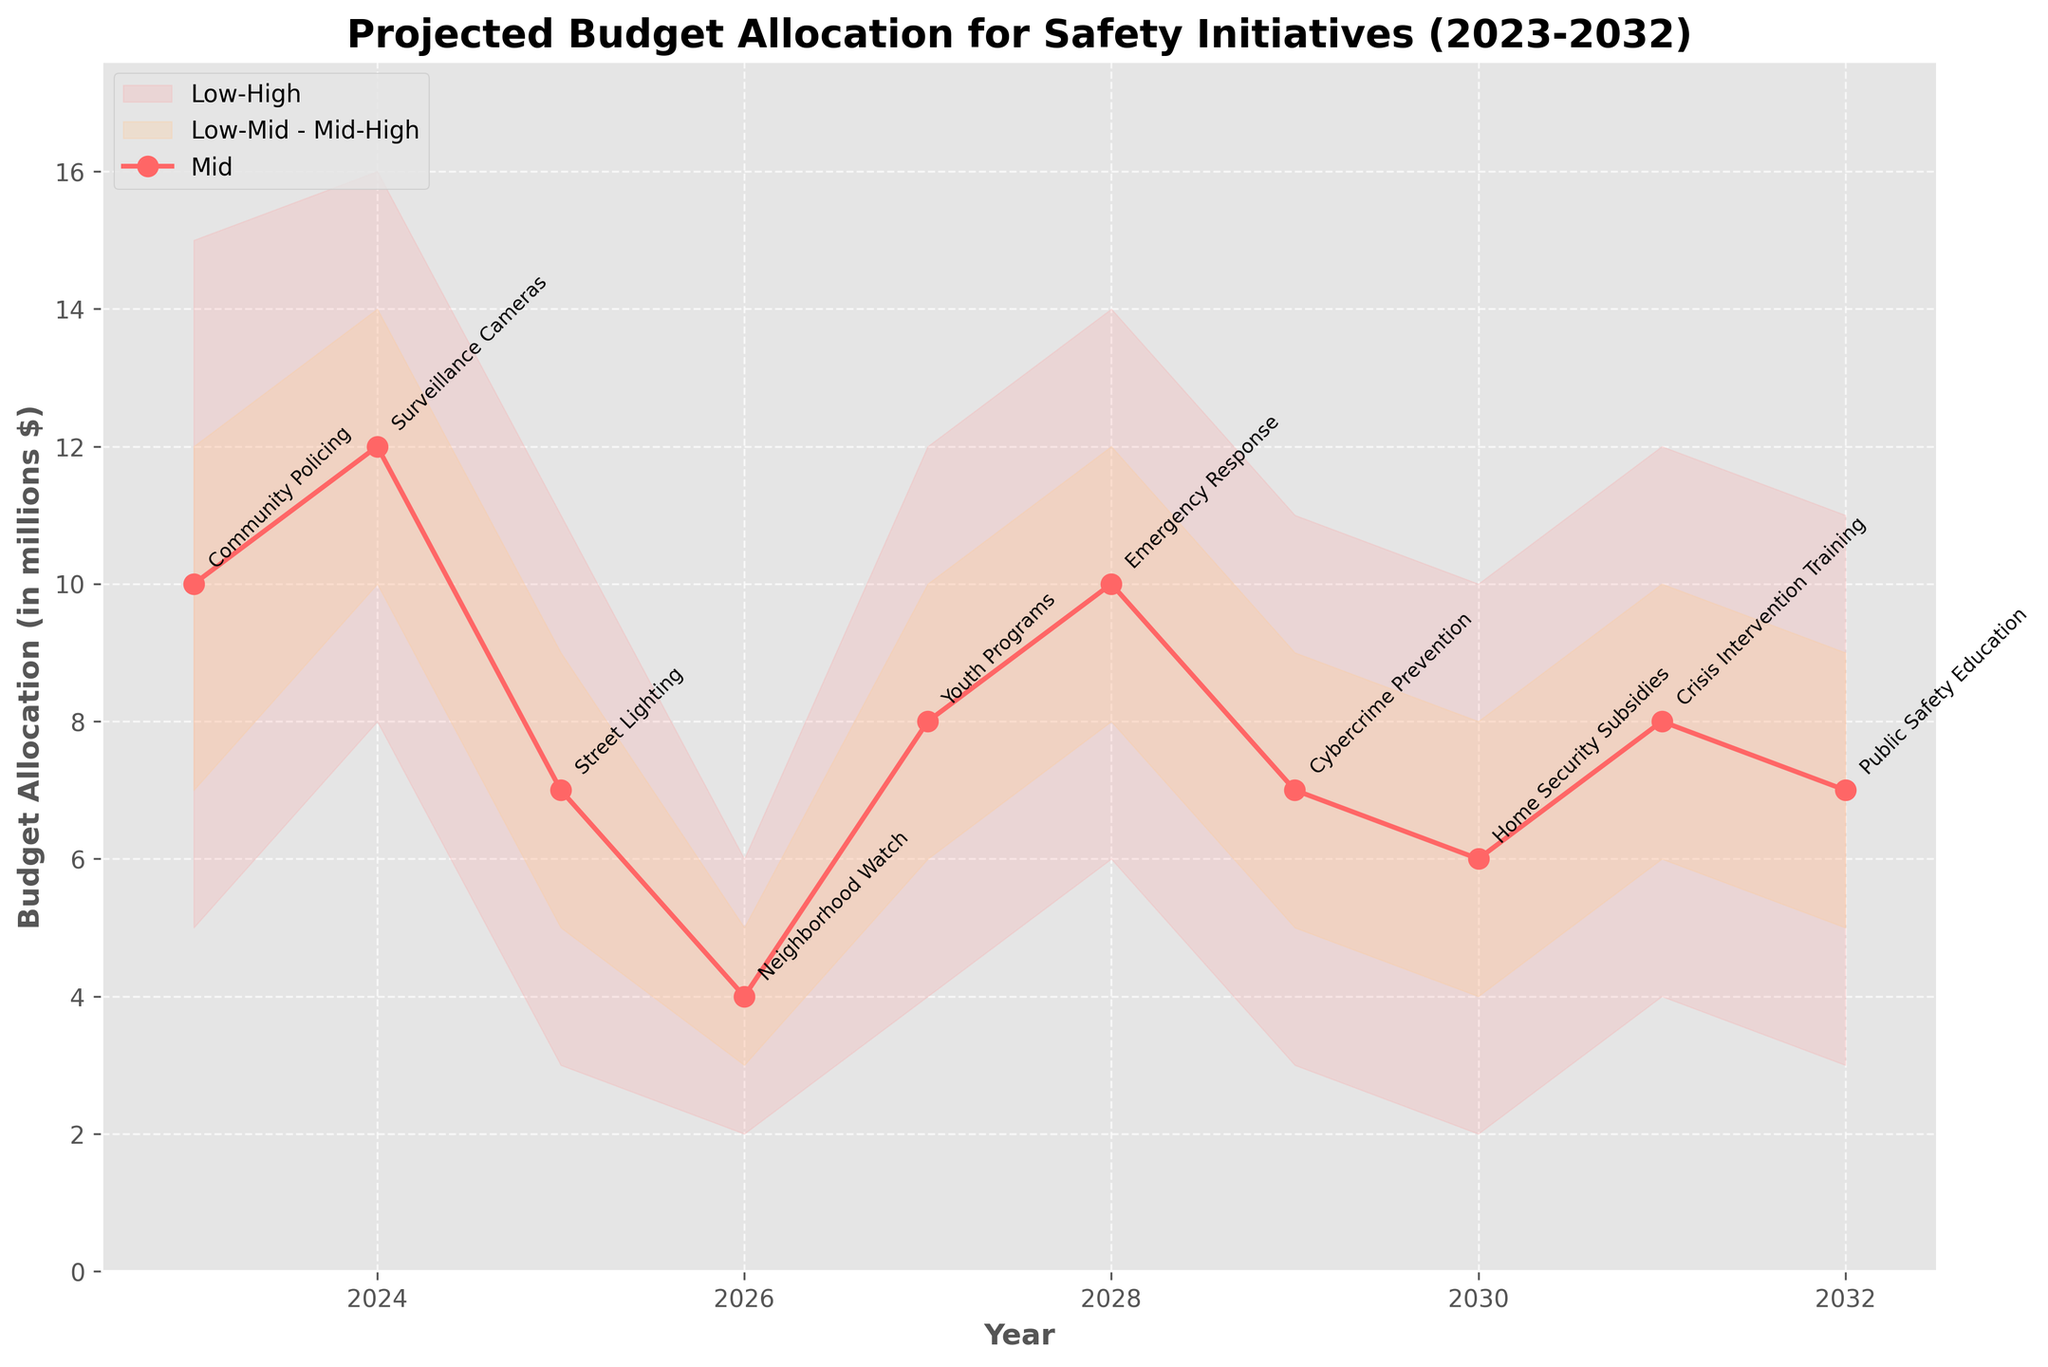What is the title of the chart? The title is located at the top of the chart and describes the overall theme or subject of the chart.
Answer: Projected Budget Allocation for Safety Initiatives (2023-2032) What is the projected budget allocation for Community Policing in 2023? The budget allocation for each initiative is represented by different points on the chart. Look for the point labeled "Community Policing" on the x-axis for the year 2023, and then trace it up to the y-axis value of the "Mid" line.
Answer: 10 million dollars Which year has the highest "High" projection for Emergency Response? The "High" projections are the top bound of the shaded areas. Locate the line segment for Emergency Response and find the year where this line reaches its highest point.
Answer: 2028 What is the difference between the "Mid" projections of Surveillance Cameras in 2024 and Cybercrime Prevention in 2029? Locate the "Mid" projections values for both years and initiatives. Then, subtract the "Mid" value of Cybercrime Prevention in 2029 from the "Mid" value of Surveillance Cameras in 2024.
Answer: 5 million dollars Compare the "Low-Mid" budget projections for Youth Programs in 2027 and Neighborhood Watch in 2026. Which one is higher? Check the "Low-Mid" budget projection values in the years 2027 and 2026 for Youth Programs and Neighborhood Watch, respectively. Compare these values.
Answer: Youth Programs How does the range of projected budget allocations for Home Security Subsidies in 2030 compare with Public Safety Education in 2032? Look at the shaded area differences (Low to High) for both initiatives in their respective years, then compare these ranges directly.
Answer: Home Security Subsidies has a smaller range than Public Safety Education What is the projected "Mid-High" value for Street Lighting in 2025? Locate the year 2025 on the x-axis and find the "Mid-High" value by tracing up to the corresponding level in the chart for Street Lighting.
Answer: 9 million dollars Are the budget projections for Crisis Intervention Training higher or lower than for Youth Programs in their respective years of 2031 and 2027, based on the "Mid" values? Compare the "Mid" projections of Crisis Intervention Training in 2031 and Youth Programs in 2027. Check which value is higher.
Answer: Equal Which initiative has the lowest "Low" budget projection in any year? Find the "Low" budget projection values for all initiatives across all years and identify the lowest value.
Answer: Neighborhood Watch in 2026 